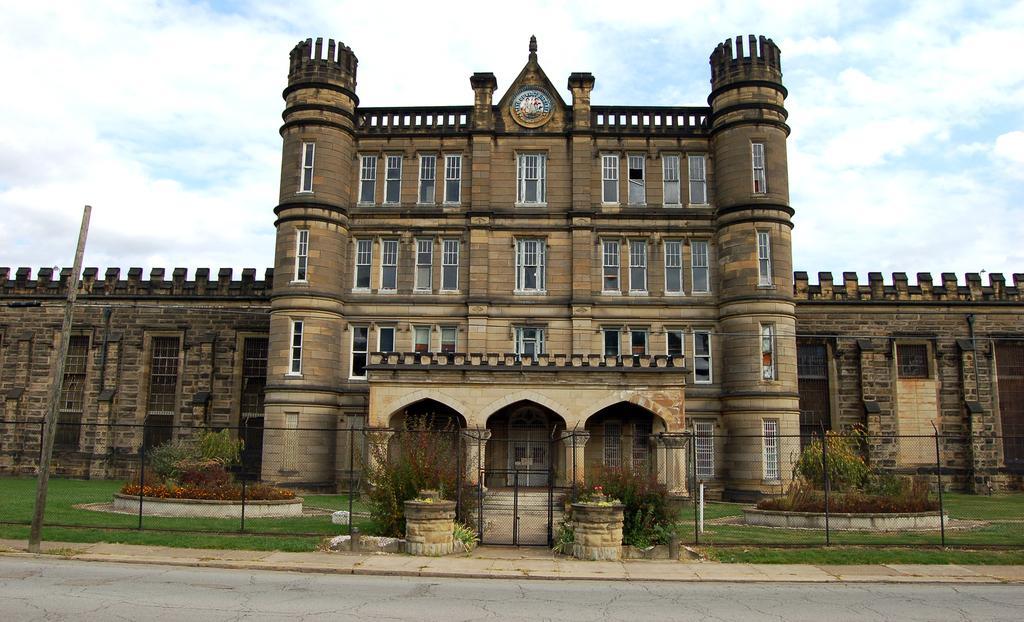How would you summarize this image in a sentence or two? At the bottom of this image, there is a road. Beside this road, there is a footpath. Beside this footpath, on which there is a pole. In the background, there is a fence, there are plants, buildings and grass on the ground and there are clouds in the sky. 